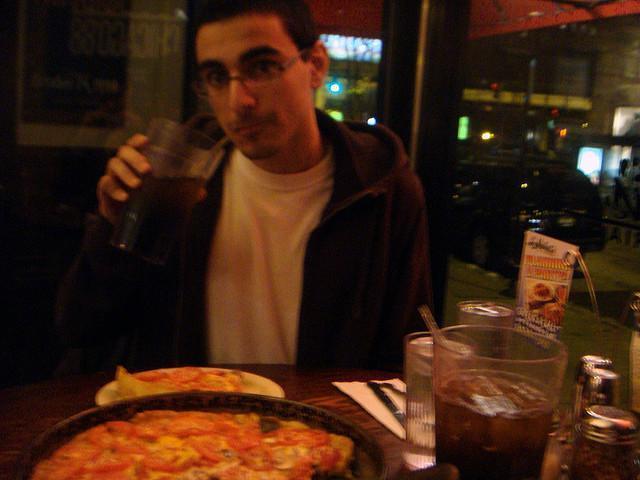What color is the soft drink drank by the man at the pizza store?
Select the accurate answer and provide justification: `Answer: choice
Rationale: srationale.`
Options: Clear, brown, blue, white. Answer: brown.
Rationale: This is obvious in the scene. 